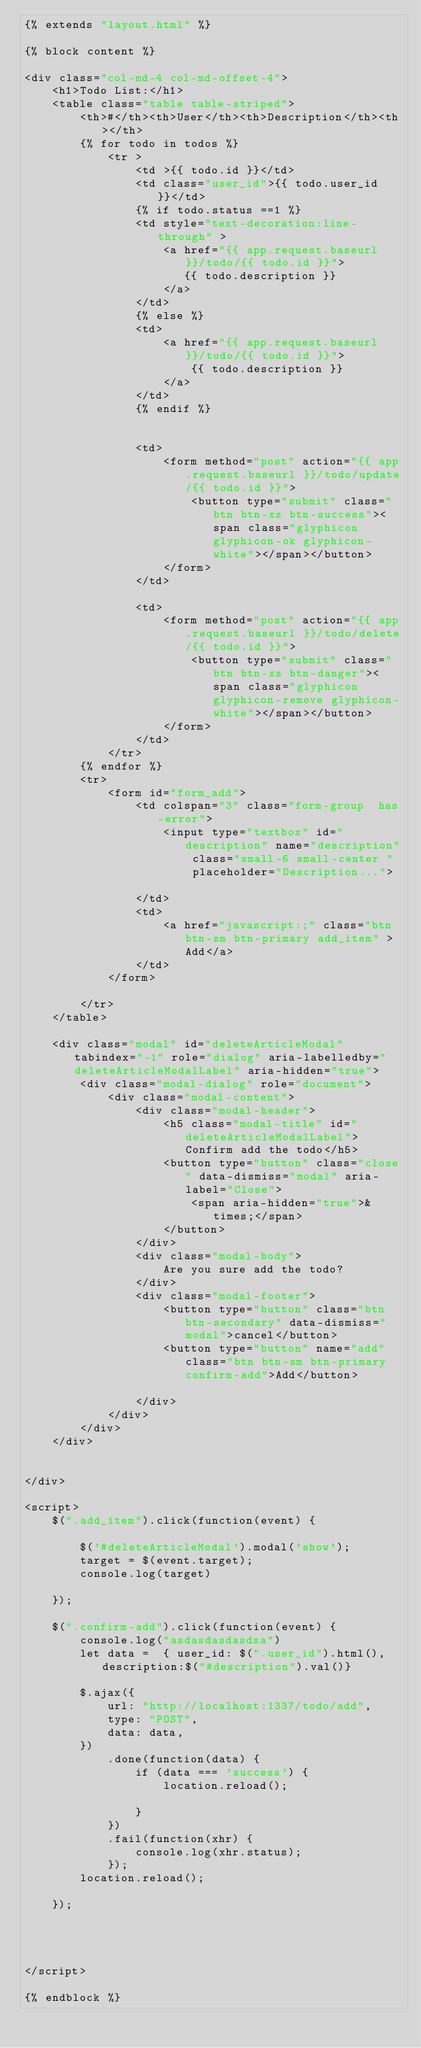Convert code to text. <code><loc_0><loc_0><loc_500><loc_500><_HTML_>{% extends "layout.html" %}

{% block content %}

<div class="col-md-4 col-md-offset-4">
    <h1>Todo List:</h1>
    <table class="table table-striped">
        <th>#</th><th>User</th><th>Description</th><th></th>
        {% for todo in todos %}
            <tr >
                <td >{{ todo.id }}</td>
                <td class="user_id">{{ todo.user_id }}</td>
                {% if todo.status ==1 %}
                <td style="text-decoration:line-through" >
                    <a href="{{ app.request.baseurl }}/todo/{{ todo.id }}">
                       {{ todo.description }}
                    </a>
                </td>
                {% else %}
                <td>
                    <a href="{{ app.request.baseurl }}/todo/{{ todo.id }}">
                        {{ todo.description }}
                    </a>
                </td>
                {% endif %}


                <td>
                    <form method="post" action="{{ app.request.baseurl }}/todo/update/{{ todo.id }}">
                        <button type="submit" class="btn btn-xs btn-success"><span class="glyphicon glyphicon-ok glyphicon-white"></span></button>
                    </form>
                </td>

                <td>
                    <form method="post" action="{{ app.request.baseurl }}/todo/delete/{{ todo.id }}">
                        <button type="submit" class="btn btn-xs btn-danger"><span class="glyphicon glyphicon-remove glyphicon-white"></span></button>
                    </form>
                </td>
            </tr>
        {% endfor %}
        <tr>
            <form id="form_add">
                <td colspan="3" class="form-group  has-error">
                    <input type="textbox" id="description" name="description" class="small-6 small-center "  placeholder="Description...">

                </td>
                <td>
                    <a href="javascript:;" class="btn btn-sm btn-primary add_item" >Add</a>
                </td>
            </form>

        </tr>
    </table>

    <div class="modal" id="deleteArticleModal" tabindex="-1" role="dialog" aria-labelledby="deleteArticleModalLabel" aria-hidden="true">
        <div class="modal-dialog" role="document">
            <div class="modal-content">
                <div class="modal-header">
                    <h5 class="modal-title" id="deleteArticleModalLabel">Confirm add the todo</h5>
                    <button type="button" class="close" data-dismiss="modal" aria-label="Close">
                        <span aria-hidden="true">&times;</span>
                    </button>
                </div>
                <div class="modal-body">
                    Are you sure add the todo?
                </div>
                <div class="modal-footer">
                    <button type="button" class="btn btn-secondary" data-dismiss="modal">cancel</button>
                    <button type="button" name="add" class="btn btn-sm btn-primary confirm-add">Add</button>

                </div>
            </div>
        </div>
    </div>


</div>

<script>
    $(".add_item").click(function(event) {

        $('#deleteArticleModal').modal('show');
        target = $(event.target);
        console.log(target)

    });

    $(".confirm-add").click(function(event) {
        console.log("asdasdasdasdsa")
        let data =  { user_id: $(".user_id").html(), description:$("#description").val()}

        $.ajax({
            url: "http://localhost:1337/todo/add",
            type: "POST",
            data: data,
        })
            .done(function(data) {
                if (data === 'success') {
                    location.reload();

                }
            })
            .fail(function(xhr) {
                console.log(xhr.status);
            });
        location.reload();

    });




</script>

{% endblock %}</code> 